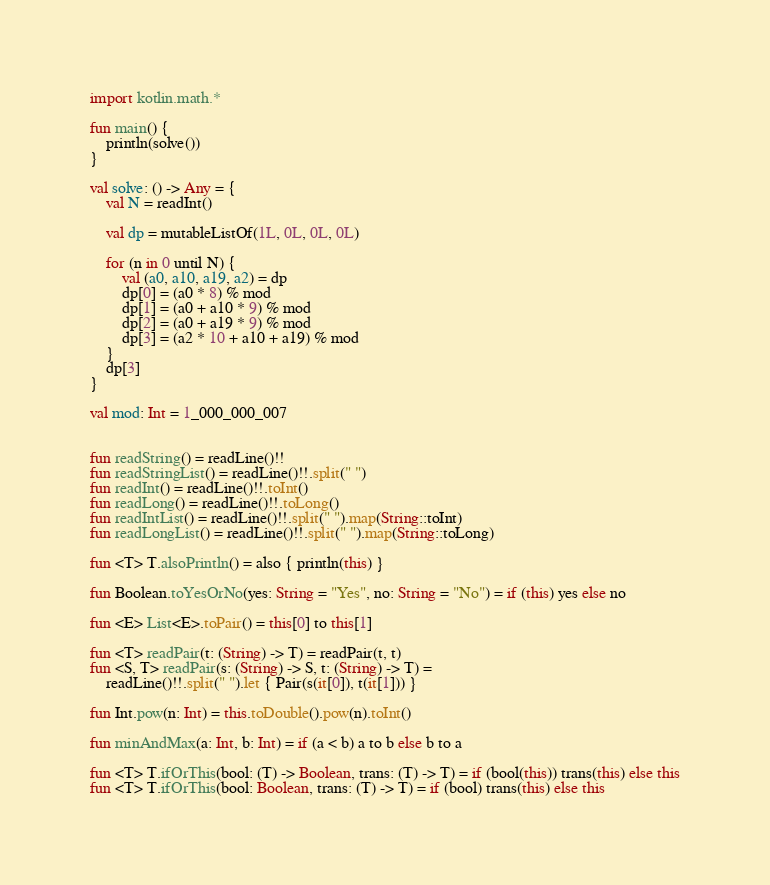<code> <loc_0><loc_0><loc_500><loc_500><_Kotlin_>import kotlin.math.*

fun main() {
    println(solve())
}

val solve: () -> Any = {
    val N = readInt()

    val dp = mutableListOf(1L, 0L, 0L, 0L)

    for (n in 0 until N) {
        val (a0, a10, a19, a2) = dp
        dp[0] = (a0 * 8) % mod
        dp[1] = (a0 + a10 * 9) % mod
        dp[2] = (a0 + a19 * 9) % mod
        dp[3] = (a2 * 10 + a10 + a19) % mod
    }
    dp[3]
}

val mod: Int = 1_000_000_007


fun readString() = readLine()!!
fun readStringList() = readLine()!!.split(" ")
fun readInt() = readLine()!!.toInt()
fun readLong() = readLine()!!.toLong()
fun readIntList() = readLine()!!.split(" ").map(String::toInt)
fun readLongList() = readLine()!!.split(" ").map(String::toLong)

fun <T> T.alsoPrintln() = also { println(this) }

fun Boolean.toYesOrNo(yes: String = "Yes", no: String = "No") = if (this) yes else no

fun <E> List<E>.toPair() = this[0] to this[1]

fun <T> readPair(t: (String) -> T) = readPair(t, t)
fun <S, T> readPair(s: (String) -> S, t: (String) -> T) =
    readLine()!!.split(" ").let { Pair(s(it[0]), t(it[1])) }

fun Int.pow(n: Int) = this.toDouble().pow(n).toInt()

fun minAndMax(a: Int, b: Int) = if (a < b) a to b else b to a

fun <T> T.ifOrThis(bool: (T) -> Boolean, trans: (T) -> T) = if (bool(this)) trans(this) else this
fun <T> T.ifOrThis(bool: Boolean, trans: (T) -> T) = if (bool) trans(this) else this</code> 